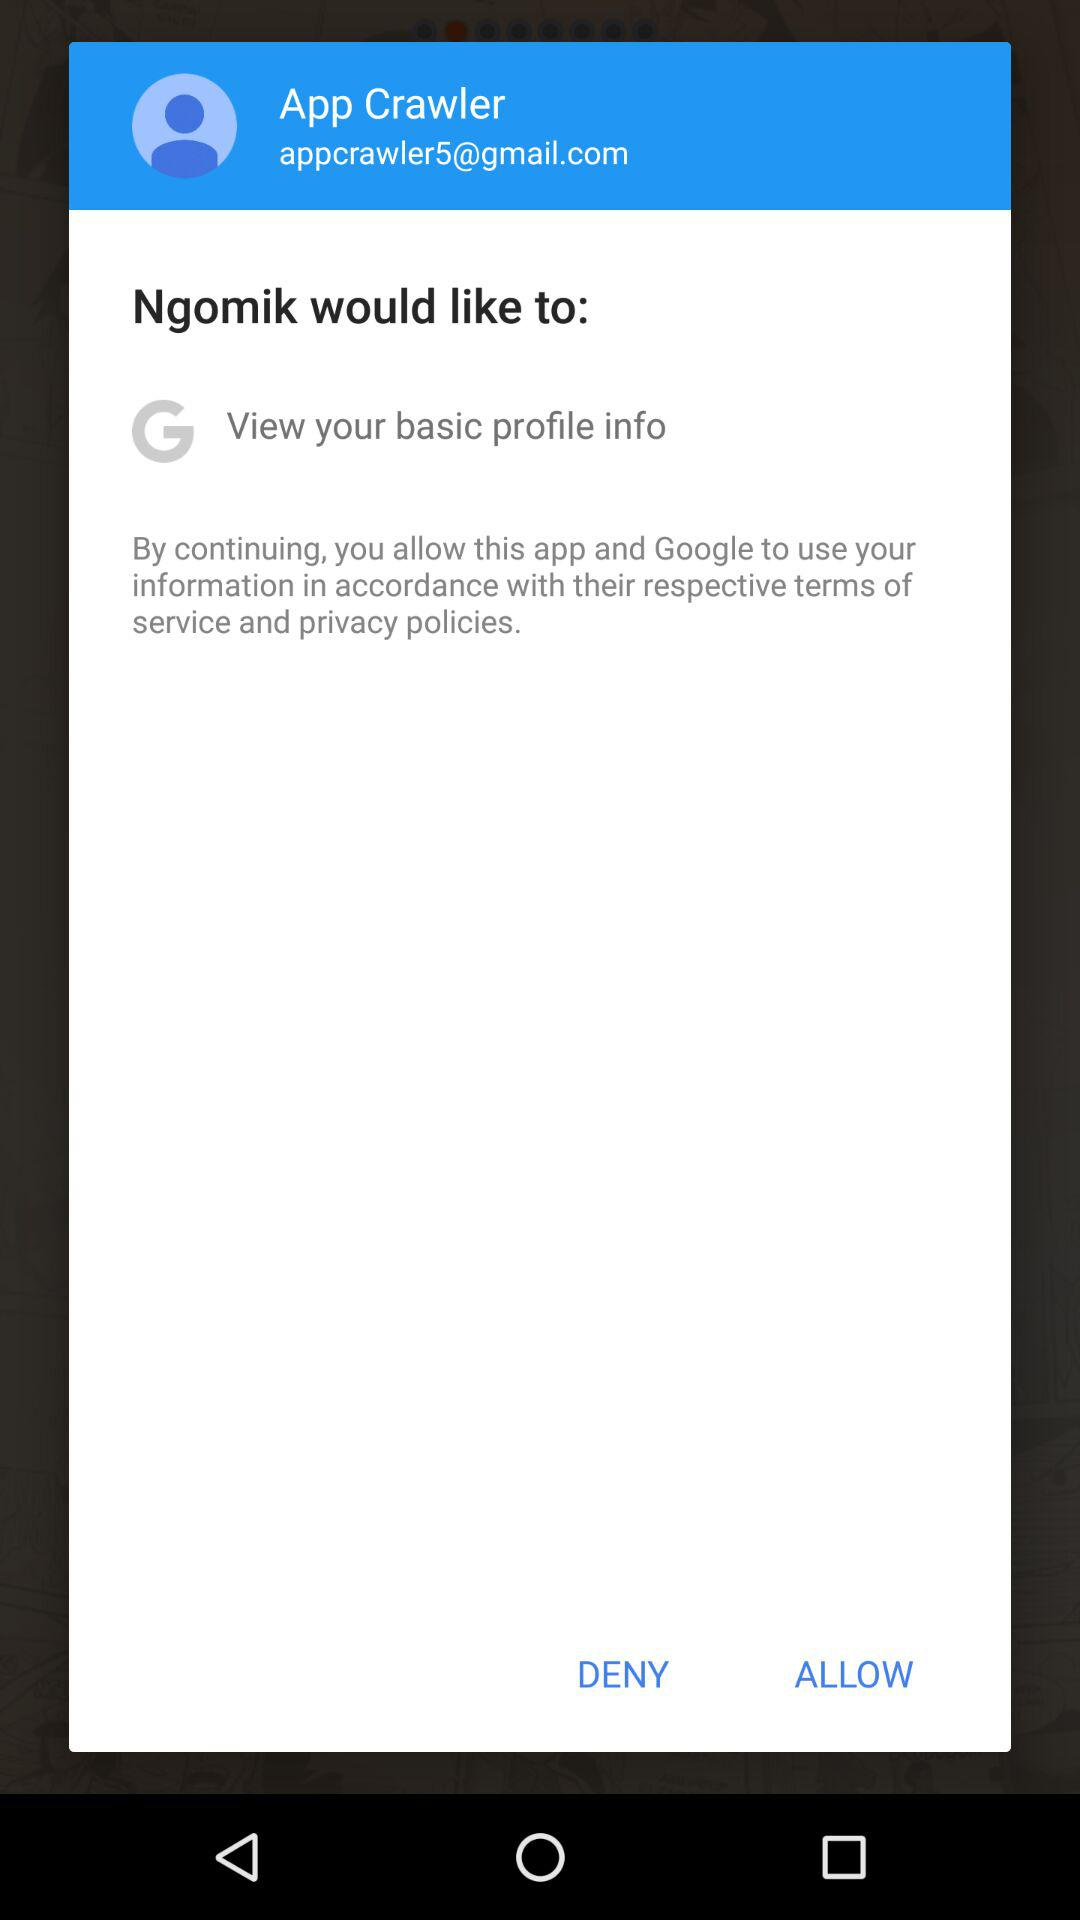What is the given Gmail ID? The given Gmail ID is appcrawler5@gmail.com. 